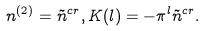<formula> <loc_0><loc_0><loc_500><loc_500>n ^ { ( 2 ) } = \tilde { n } ^ { c r } , K ( l ) = - \pi ^ { l } \tilde { n } ^ { c r } .</formula> 